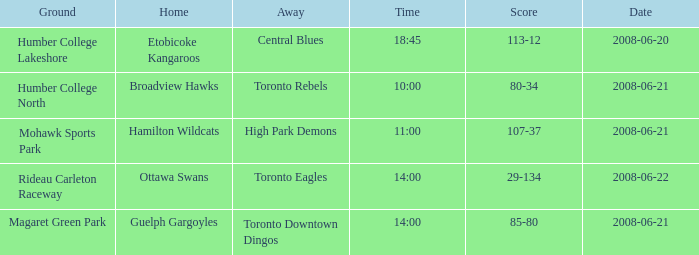What is the Date with a Home that is hamilton wildcats? 2008-06-21. 